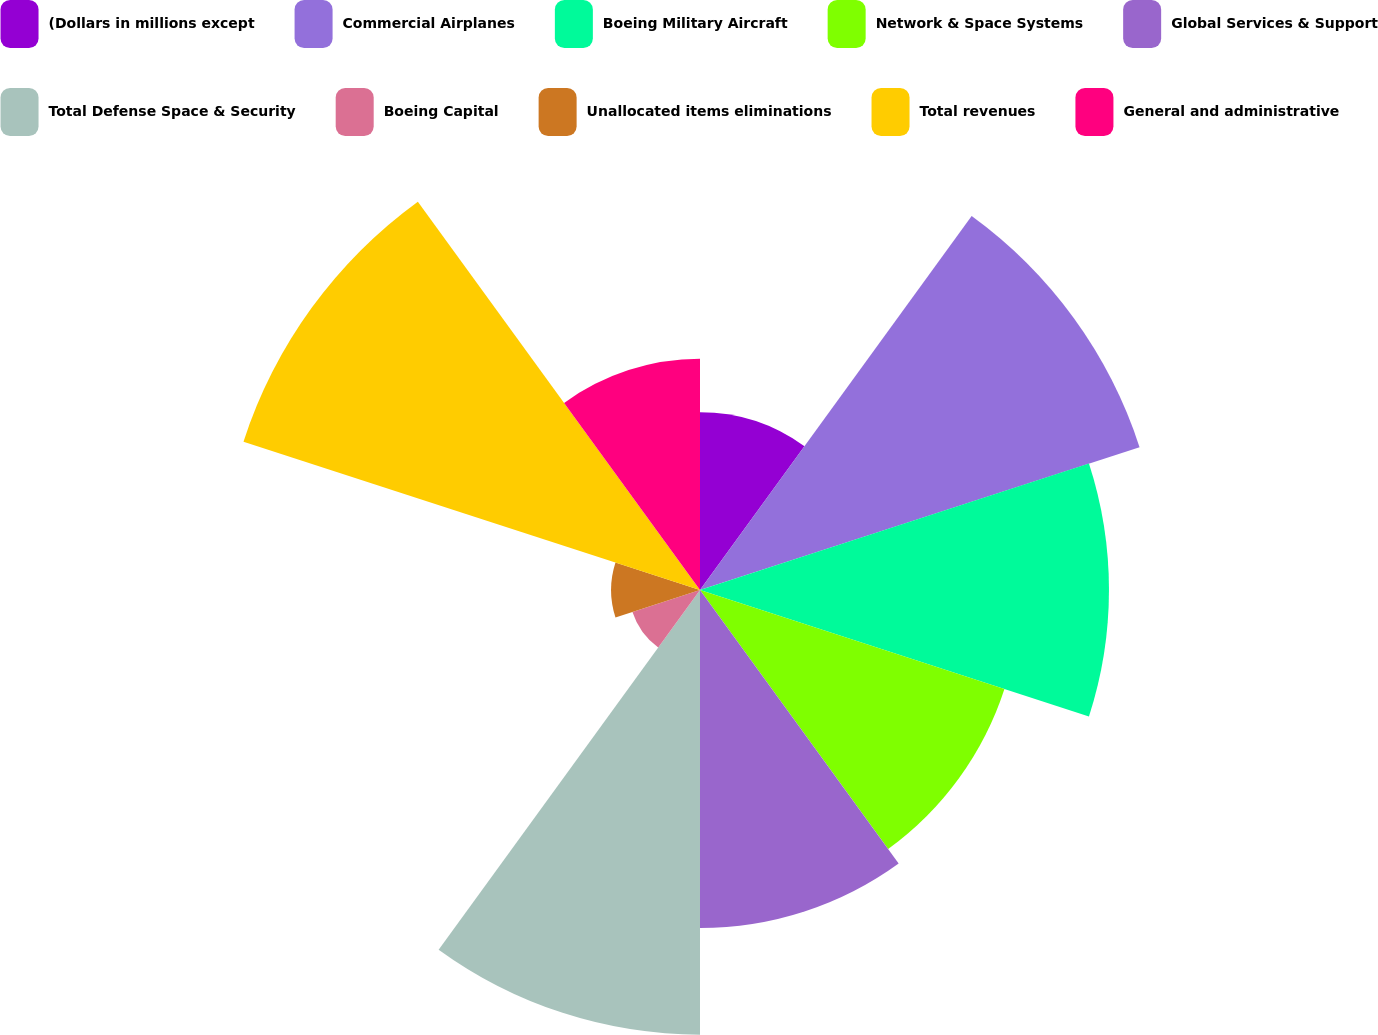Convert chart to OTSL. <chart><loc_0><loc_0><loc_500><loc_500><pie_chart><fcel>(Dollars in millions except<fcel>Commercial Airplanes<fcel>Boeing Military Aircraft<fcel>Network & Space Systems<fcel>Global Services & Support<fcel>Total Defense Space & Security<fcel>Boeing Capital<fcel>Unallocated items eliminations<fcel>Total revenues<fcel>General and administrative<nl><fcel>5.88%<fcel>15.29%<fcel>13.53%<fcel>10.59%<fcel>11.18%<fcel>14.71%<fcel>2.35%<fcel>2.94%<fcel>15.88%<fcel>7.65%<nl></chart> 